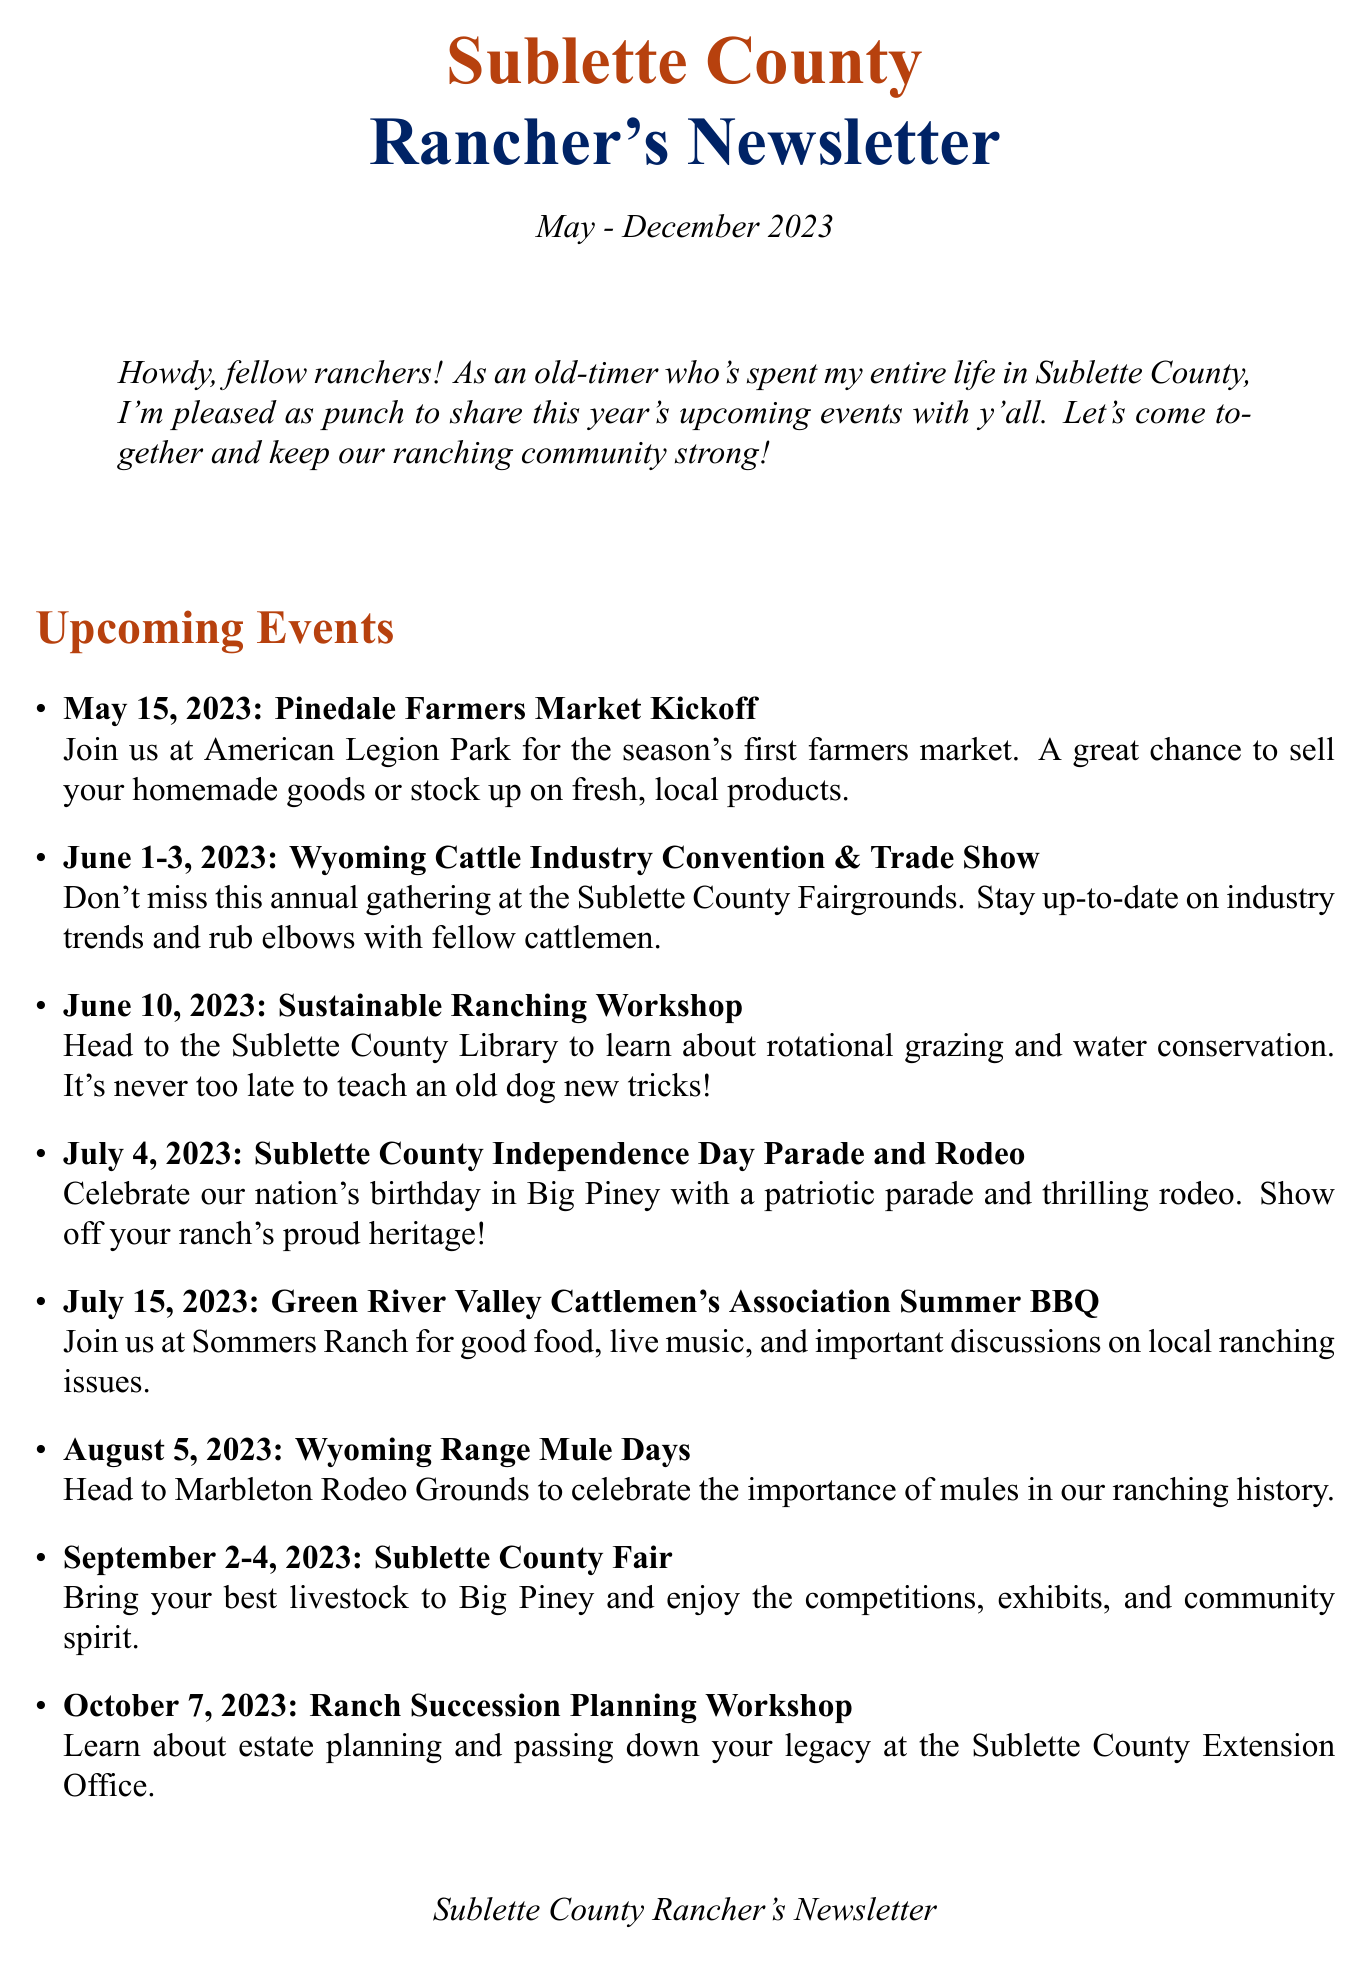What is the date of the Pinedale Farmers Market Kickoff? The date listed for the Pinedale Farmers Market Kickoff in the document is May 15, 2023.
Answer: May 15, 2023 What event takes place on June 10, 2023? The event scheduled for June 10, 2023, is the Sustainable Ranching Workshop.
Answer: Sustainable Ranching Workshop What is the focus of the Ranch Succession Planning Workshop? The focus of the Ranch Succession Planning Workshop is on estate planning and passing down ranches to the next generation.
Answer: Estate planning What significant holiday is celebrated during the event on July 4, 2023? The significant holiday celebrated during the event on July 4, 2023, is Independence Day.
Answer: Independence Day Which event features livestock shows and competitions? The event that features livestock shows and competitions is the Sublette County Fair.
Answer: Sublette County Fair How many days does the Wyoming Cattle Industry Convention & Trade Show last? The Wyoming Cattle Industry Convention & Trade Show lasts for three days.
Answer: Three days What type of meal is served at the Veterans Day Appreciation Breakfast? The type of meal served at the Veterans Day Appreciation Breakfast is breakfast.
Answer: Breakfast What is the location of the Winter Cattlemen's Meeting? The location of the Winter Cattlemen's Meeting is the Sublette County Fairgrounds.
Answer: Sublette County Fairgrounds What community value is highlighted in the newsletter? The community value highlighted in the newsletter is sticking together.
Answer: Sticking together 